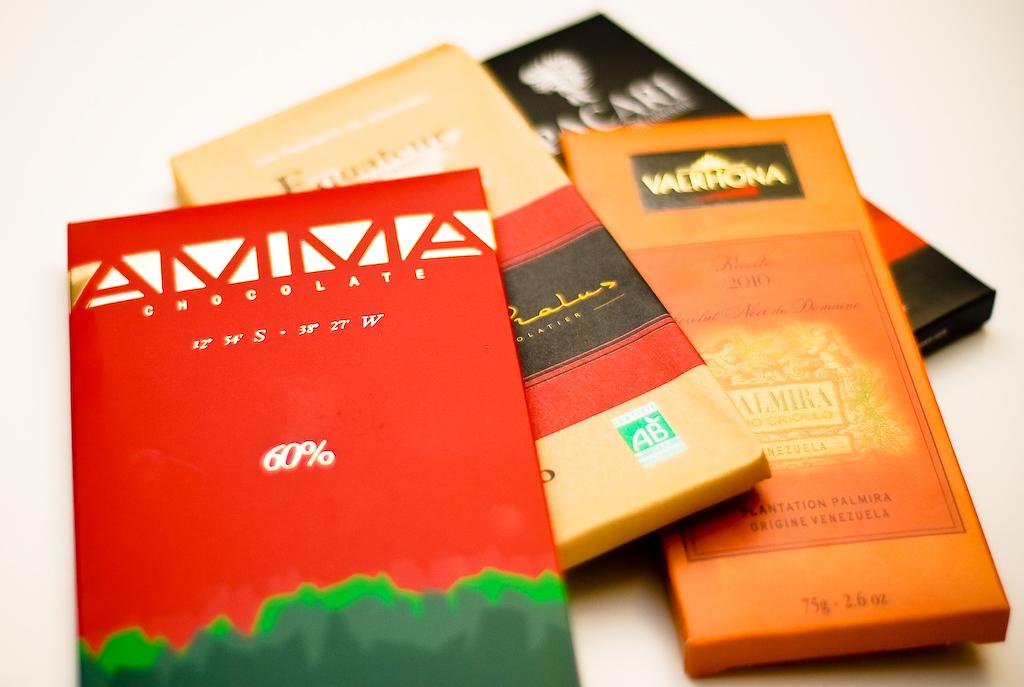What is the brand of coffee?
Ensure brevity in your answer.  Unanswerable. 